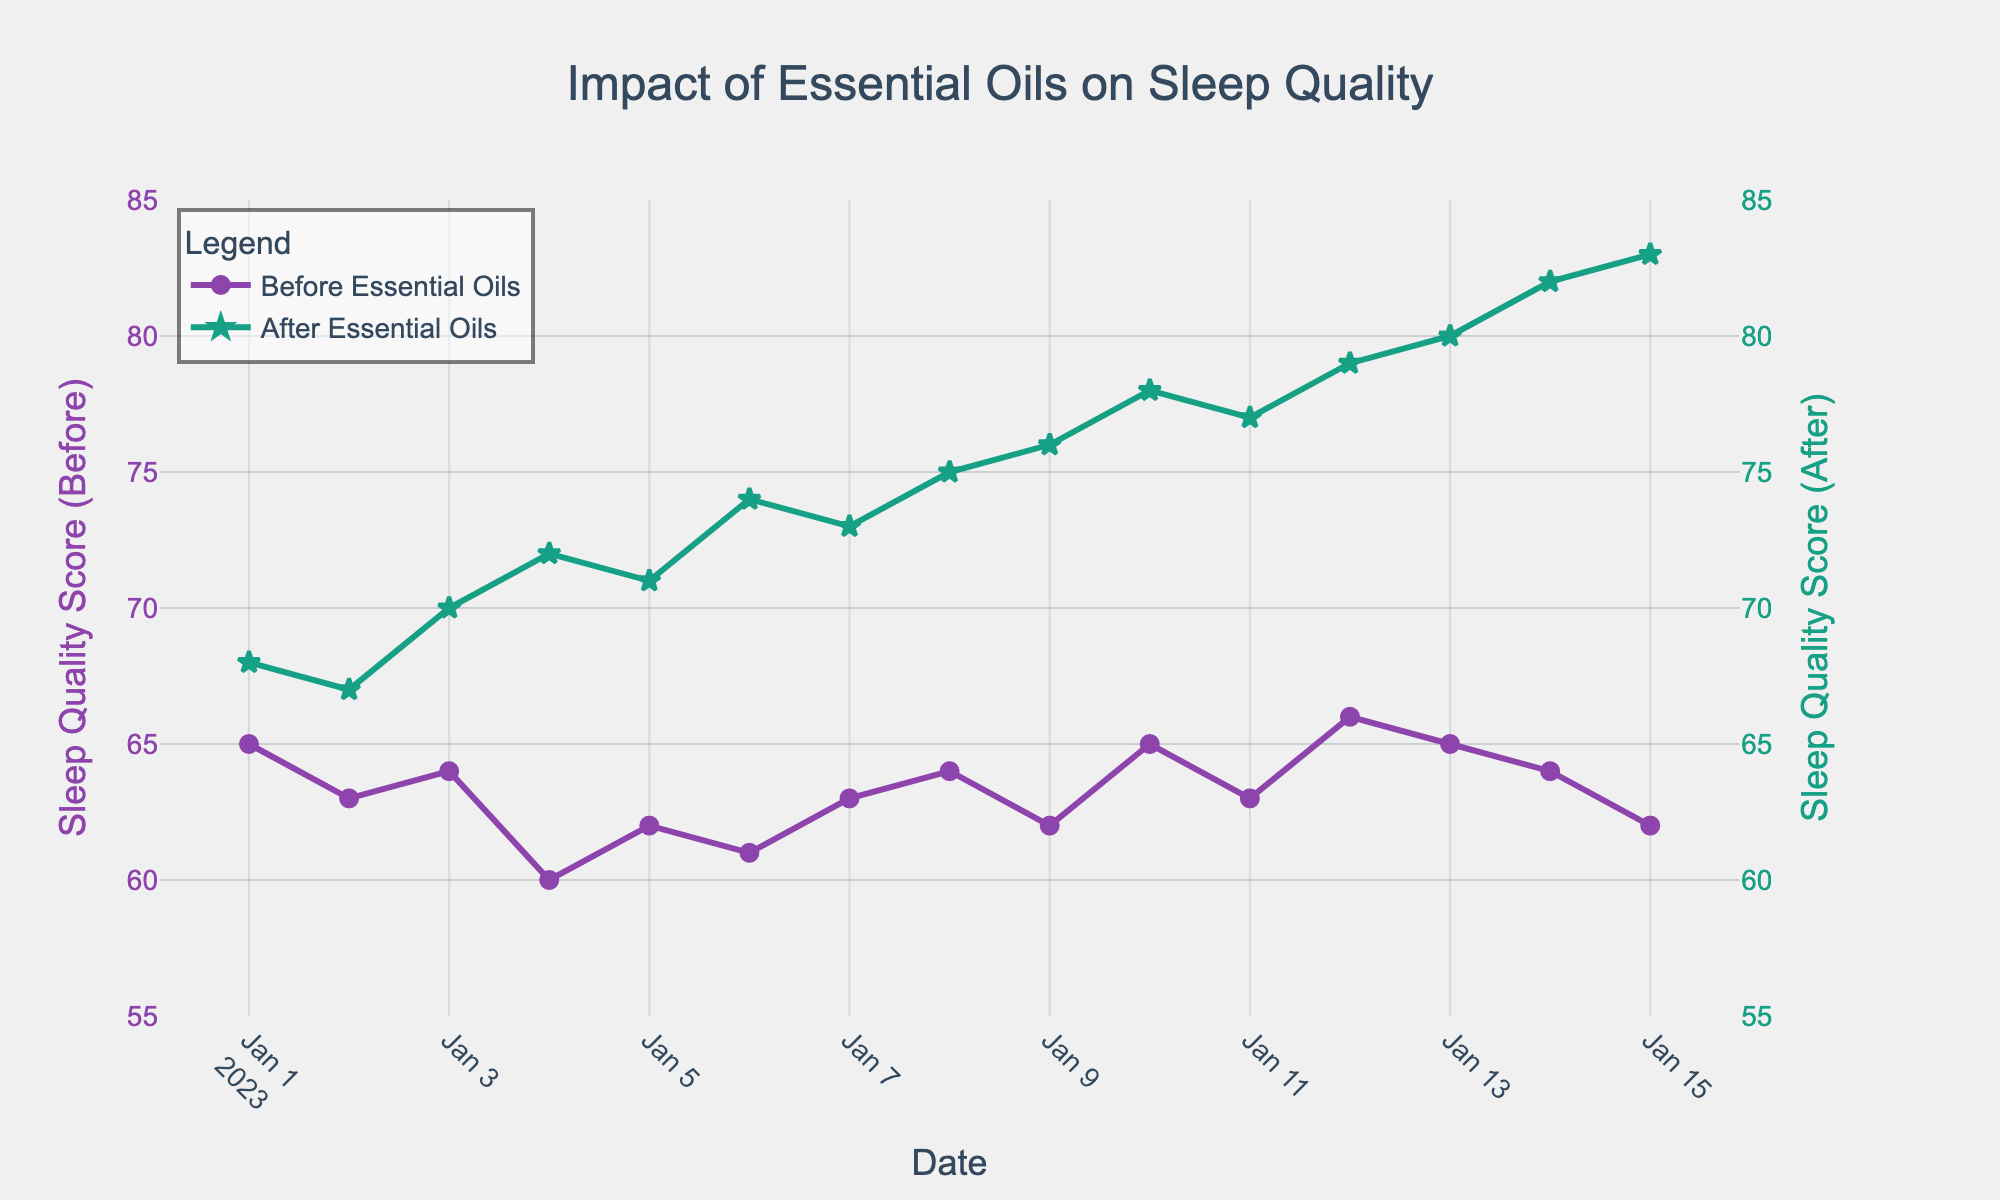What is the title of the figure? The title of the figure is located at the top and is displayed prominently in a larger, bold font.
Answer: Impact of Essential Oils on Sleep Quality How many distinct points are plotted for sleep quality before using essential oils? Each data point corresponds to a date, and they appear as circles on the figure. Counting these circles will give the number of distinct points.
Answer: 15 What color is used to represent sleep quality after using essential oils? The figure uses distinct colors for clarity, where the sleep quality after using essential oils is represented with a specific color. The visual observation shows the line and markers in green.
Answer: Green On what date did sleep quality before essential oils fall to its lowest? Observing the scatter plot data points, the lowest point on the 'Before Essential Oils' curve needs to be identified.
Answer: 2023-01-04 What was the sleep quality score after using essential oils on January 5th? Locate the date January 5th on the x-axis and check the corresponding value on the 'After Essential Oils' trace, which uses green stars as markers.
Answer: 71 How much did sleep quality improve on January 15th compared to before using essential oils? Find the difference between the sleep quality scores before and after using essential oils on January 15th. The values are 62 and 83, respectively.
Answer: 21 Which date shows the highest sleep quality score after incorporating essential oils? Look for the highest point on the 'After Essential Oils' line, which is marked by green stars, and note the corresponding date on the x-axis.
Answer: January 15th What is the overall trend in sleep quality after incorporating essential oils? Observe the 'After Essential Oils' trace from start to end. Notice whether the values show an increasing, decreasing, or stable pattern over time.
Answer: Increasing Calculate the average sleep quality score before using essential oils over the recorded period. Sum all the sleep quality scores before essential oils and then divide by the number of days (data points). The scores are [65, 63, 64, 60, 62, 61, 63, 64, 62, 65, 63, 66, 65, 64, 62], summing to 919. Divide 919 by 15 (number of data points).
Answer: 61.3 Compare the sleep quality on January 10th with that on January 1st after using essential oils. Find the sleep quality scores after using essential oils on both January 1st and January 10th from the 'After Essential Oils' trace. Compare 68 (January 1st) with 78 (January 10th).
Answer: January 10th > January 1st 